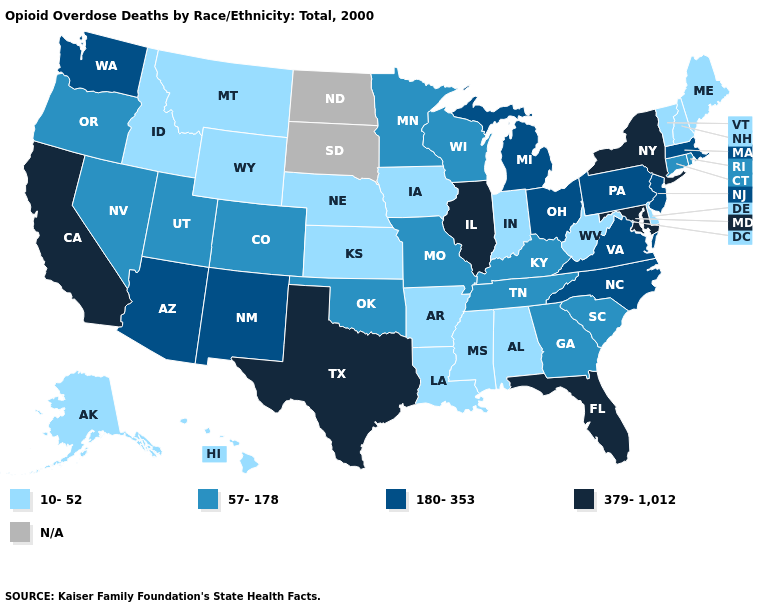Does Wyoming have the lowest value in the USA?
Short answer required. Yes. Is the legend a continuous bar?
Quick response, please. No. What is the lowest value in the MidWest?
Concise answer only. 10-52. Name the states that have a value in the range N/A?
Quick response, please. North Dakota, South Dakota. Among the states that border New Mexico , which have the lowest value?
Keep it brief. Colorado, Oklahoma, Utah. Does the first symbol in the legend represent the smallest category?
Keep it brief. Yes. Does the map have missing data?
Concise answer only. Yes. Does Wyoming have the lowest value in the West?
Write a very short answer. Yes. Name the states that have a value in the range 10-52?
Quick response, please. Alabama, Alaska, Arkansas, Delaware, Hawaii, Idaho, Indiana, Iowa, Kansas, Louisiana, Maine, Mississippi, Montana, Nebraska, New Hampshire, Vermont, West Virginia, Wyoming. Is the legend a continuous bar?
Answer briefly. No. Among the states that border North Dakota , does Minnesota have the highest value?
Give a very brief answer. Yes. Name the states that have a value in the range N/A?
Be succinct. North Dakota, South Dakota. What is the value of Pennsylvania?
Concise answer only. 180-353. 